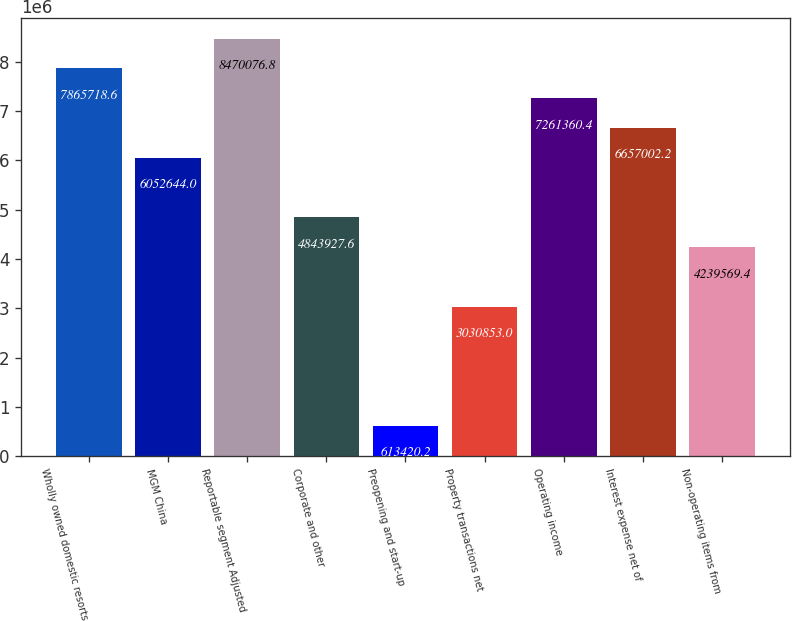Convert chart. <chart><loc_0><loc_0><loc_500><loc_500><bar_chart><fcel>Wholly owned domestic resorts<fcel>MGM China<fcel>Reportable segment Adjusted<fcel>Corporate and other<fcel>Preopening and start-up<fcel>Property transactions net<fcel>Operating income<fcel>Interest expense net of<fcel>Non-operating items from<nl><fcel>7.86572e+06<fcel>6.05264e+06<fcel>8.47008e+06<fcel>4.84393e+06<fcel>613420<fcel>3.03085e+06<fcel>7.26136e+06<fcel>6.657e+06<fcel>4.23957e+06<nl></chart> 